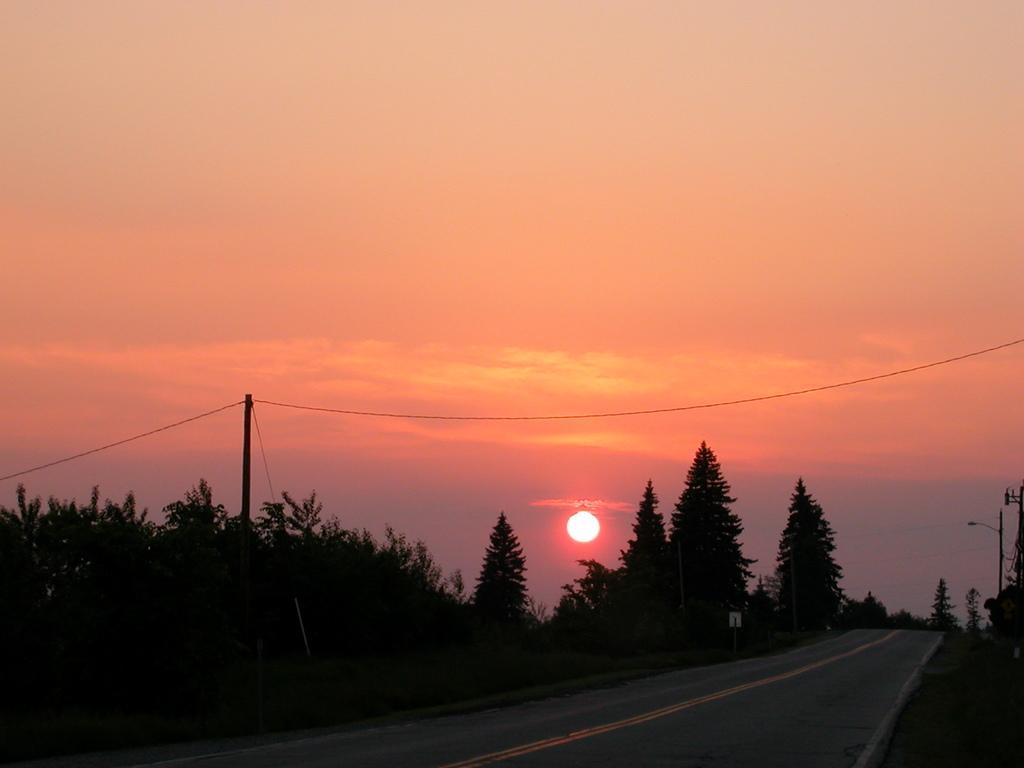Can you describe this image briefly? In this image we can see road, trees, pole, sun and sky. 